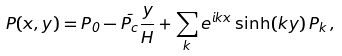Convert formula to latex. <formula><loc_0><loc_0><loc_500><loc_500>P ( x , y ) = P _ { 0 } - \bar { P _ { c } } \frac { y } { H } + \sum _ { k } e ^ { i k x } \sinh ( k y ) \, P _ { k } \, ,</formula> 